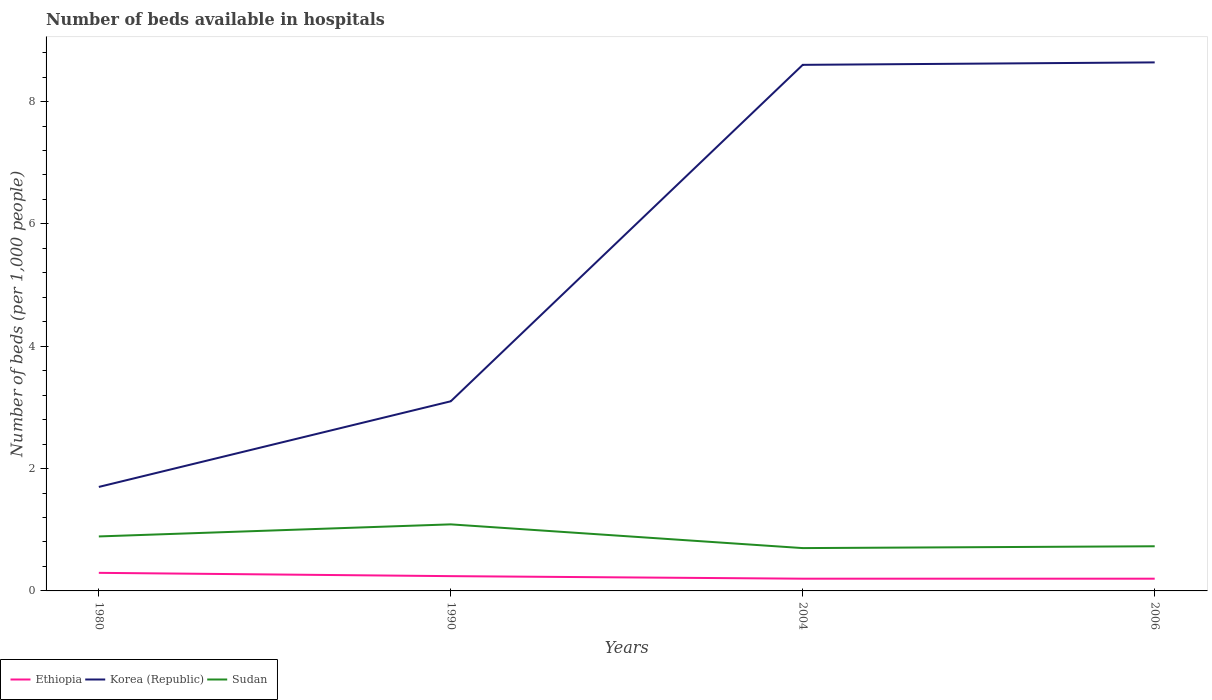Does the line corresponding to Sudan intersect with the line corresponding to Korea (Republic)?
Offer a terse response. No. Is the number of lines equal to the number of legend labels?
Offer a terse response. Yes. In which year was the number of beds in the hospiatls of in Ethiopia maximum?
Offer a terse response. 2004. What is the total number of beds in the hospiatls of in Ethiopia in the graph?
Keep it short and to the point. 0.1. What is the difference between the highest and the second highest number of beds in the hospiatls of in Sudan?
Provide a succinct answer. 0.39. What is the difference between the highest and the lowest number of beds in the hospiatls of in Korea (Republic)?
Your response must be concise. 2. Is the number of beds in the hospiatls of in Korea (Republic) strictly greater than the number of beds in the hospiatls of in Ethiopia over the years?
Offer a very short reply. No. How many years are there in the graph?
Ensure brevity in your answer.  4. Does the graph contain any zero values?
Offer a terse response. No. Where does the legend appear in the graph?
Provide a short and direct response. Bottom left. How are the legend labels stacked?
Your response must be concise. Horizontal. What is the title of the graph?
Ensure brevity in your answer.  Number of beds available in hospitals. What is the label or title of the X-axis?
Your answer should be compact. Years. What is the label or title of the Y-axis?
Offer a terse response. Number of beds (per 1,0 people). What is the Number of beds (per 1,000 people) of Ethiopia in 1980?
Offer a very short reply. 0.3. What is the Number of beds (per 1,000 people) in Korea (Republic) in 1980?
Give a very brief answer. 1.7. What is the Number of beds (per 1,000 people) of Sudan in 1980?
Provide a short and direct response. 0.89. What is the Number of beds (per 1,000 people) of Ethiopia in 1990?
Offer a terse response. 0.24. What is the Number of beds (per 1,000 people) of Korea (Republic) in 1990?
Offer a terse response. 3.1. What is the Number of beds (per 1,000 people) of Sudan in 1990?
Your response must be concise. 1.09. What is the Number of beds (per 1,000 people) in Ethiopia in 2004?
Your response must be concise. 0.2. What is the Number of beds (per 1,000 people) in Ethiopia in 2006?
Give a very brief answer. 0.2. What is the Number of beds (per 1,000 people) of Korea (Republic) in 2006?
Keep it short and to the point. 8.64. What is the Number of beds (per 1,000 people) in Sudan in 2006?
Provide a succinct answer. 0.73. Across all years, what is the maximum Number of beds (per 1,000 people) of Ethiopia?
Keep it short and to the point. 0.3. Across all years, what is the maximum Number of beds (per 1,000 people) of Korea (Republic)?
Your response must be concise. 8.64. Across all years, what is the maximum Number of beds (per 1,000 people) in Sudan?
Make the answer very short. 1.09. Across all years, what is the minimum Number of beds (per 1,000 people) of Ethiopia?
Your answer should be very brief. 0.2. Across all years, what is the minimum Number of beds (per 1,000 people) of Korea (Republic)?
Your answer should be compact. 1.7. What is the total Number of beds (per 1,000 people) in Ethiopia in the graph?
Give a very brief answer. 0.94. What is the total Number of beds (per 1,000 people) in Korea (Republic) in the graph?
Ensure brevity in your answer.  22.04. What is the total Number of beds (per 1,000 people) in Sudan in the graph?
Offer a terse response. 3.41. What is the difference between the Number of beds (per 1,000 people) of Ethiopia in 1980 and that in 1990?
Offer a very short reply. 0.05. What is the difference between the Number of beds (per 1,000 people) in Korea (Republic) in 1980 and that in 1990?
Provide a succinct answer. -1.4. What is the difference between the Number of beds (per 1,000 people) of Sudan in 1980 and that in 1990?
Your answer should be compact. -0.2. What is the difference between the Number of beds (per 1,000 people) in Ethiopia in 1980 and that in 2004?
Give a very brief answer. 0.1. What is the difference between the Number of beds (per 1,000 people) in Sudan in 1980 and that in 2004?
Your answer should be compact. 0.19. What is the difference between the Number of beds (per 1,000 people) of Ethiopia in 1980 and that in 2006?
Keep it short and to the point. 0.1. What is the difference between the Number of beds (per 1,000 people) in Korea (Republic) in 1980 and that in 2006?
Provide a succinct answer. -6.94. What is the difference between the Number of beds (per 1,000 people) in Sudan in 1980 and that in 2006?
Your response must be concise. 0.16. What is the difference between the Number of beds (per 1,000 people) of Ethiopia in 1990 and that in 2004?
Provide a succinct answer. 0.04. What is the difference between the Number of beds (per 1,000 people) in Korea (Republic) in 1990 and that in 2004?
Keep it short and to the point. -5.5. What is the difference between the Number of beds (per 1,000 people) of Sudan in 1990 and that in 2004?
Offer a very short reply. 0.39. What is the difference between the Number of beds (per 1,000 people) of Ethiopia in 1990 and that in 2006?
Give a very brief answer. 0.04. What is the difference between the Number of beds (per 1,000 people) in Korea (Republic) in 1990 and that in 2006?
Offer a terse response. -5.54. What is the difference between the Number of beds (per 1,000 people) in Sudan in 1990 and that in 2006?
Keep it short and to the point. 0.36. What is the difference between the Number of beds (per 1,000 people) in Ethiopia in 2004 and that in 2006?
Your response must be concise. 0. What is the difference between the Number of beds (per 1,000 people) in Korea (Republic) in 2004 and that in 2006?
Make the answer very short. -0.04. What is the difference between the Number of beds (per 1,000 people) in Sudan in 2004 and that in 2006?
Make the answer very short. -0.03. What is the difference between the Number of beds (per 1,000 people) in Ethiopia in 1980 and the Number of beds (per 1,000 people) in Korea (Republic) in 1990?
Keep it short and to the point. -2.8. What is the difference between the Number of beds (per 1,000 people) of Ethiopia in 1980 and the Number of beds (per 1,000 people) of Sudan in 1990?
Give a very brief answer. -0.79. What is the difference between the Number of beds (per 1,000 people) of Korea (Republic) in 1980 and the Number of beds (per 1,000 people) of Sudan in 1990?
Offer a terse response. 0.61. What is the difference between the Number of beds (per 1,000 people) of Ethiopia in 1980 and the Number of beds (per 1,000 people) of Korea (Republic) in 2004?
Keep it short and to the point. -8.3. What is the difference between the Number of beds (per 1,000 people) of Ethiopia in 1980 and the Number of beds (per 1,000 people) of Sudan in 2004?
Provide a succinct answer. -0.4. What is the difference between the Number of beds (per 1,000 people) of Ethiopia in 1980 and the Number of beds (per 1,000 people) of Korea (Republic) in 2006?
Provide a succinct answer. -8.34. What is the difference between the Number of beds (per 1,000 people) in Ethiopia in 1980 and the Number of beds (per 1,000 people) in Sudan in 2006?
Ensure brevity in your answer.  -0.43. What is the difference between the Number of beds (per 1,000 people) in Korea (Republic) in 1980 and the Number of beds (per 1,000 people) in Sudan in 2006?
Your response must be concise. 0.97. What is the difference between the Number of beds (per 1,000 people) in Ethiopia in 1990 and the Number of beds (per 1,000 people) in Korea (Republic) in 2004?
Offer a terse response. -8.36. What is the difference between the Number of beds (per 1,000 people) of Ethiopia in 1990 and the Number of beds (per 1,000 people) of Sudan in 2004?
Your answer should be very brief. -0.46. What is the difference between the Number of beds (per 1,000 people) in Korea (Republic) in 1990 and the Number of beds (per 1,000 people) in Sudan in 2004?
Your answer should be compact. 2.4. What is the difference between the Number of beds (per 1,000 people) of Ethiopia in 1990 and the Number of beds (per 1,000 people) of Korea (Republic) in 2006?
Give a very brief answer. -8.4. What is the difference between the Number of beds (per 1,000 people) in Ethiopia in 1990 and the Number of beds (per 1,000 people) in Sudan in 2006?
Make the answer very short. -0.49. What is the difference between the Number of beds (per 1,000 people) in Korea (Republic) in 1990 and the Number of beds (per 1,000 people) in Sudan in 2006?
Provide a short and direct response. 2.37. What is the difference between the Number of beds (per 1,000 people) of Ethiopia in 2004 and the Number of beds (per 1,000 people) of Korea (Republic) in 2006?
Your response must be concise. -8.44. What is the difference between the Number of beds (per 1,000 people) in Ethiopia in 2004 and the Number of beds (per 1,000 people) in Sudan in 2006?
Your answer should be compact. -0.53. What is the difference between the Number of beds (per 1,000 people) of Korea (Republic) in 2004 and the Number of beds (per 1,000 people) of Sudan in 2006?
Keep it short and to the point. 7.87. What is the average Number of beds (per 1,000 people) of Ethiopia per year?
Your response must be concise. 0.23. What is the average Number of beds (per 1,000 people) of Korea (Republic) per year?
Your response must be concise. 5.51. What is the average Number of beds (per 1,000 people) of Sudan per year?
Your answer should be very brief. 0.85. In the year 1980, what is the difference between the Number of beds (per 1,000 people) of Ethiopia and Number of beds (per 1,000 people) of Korea (Republic)?
Your answer should be compact. -1.4. In the year 1980, what is the difference between the Number of beds (per 1,000 people) in Ethiopia and Number of beds (per 1,000 people) in Sudan?
Give a very brief answer. -0.6. In the year 1980, what is the difference between the Number of beds (per 1,000 people) in Korea (Republic) and Number of beds (per 1,000 people) in Sudan?
Offer a very short reply. 0.81. In the year 1990, what is the difference between the Number of beds (per 1,000 people) of Ethiopia and Number of beds (per 1,000 people) of Korea (Republic)?
Your answer should be very brief. -2.86. In the year 1990, what is the difference between the Number of beds (per 1,000 people) of Ethiopia and Number of beds (per 1,000 people) of Sudan?
Offer a very short reply. -0.85. In the year 1990, what is the difference between the Number of beds (per 1,000 people) in Korea (Republic) and Number of beds (per 1,000 people) in Sudan?
Your answer should be compact. 2.01. In the year 2004, what is the difference between the Number of beds (per 1,000 people) in Ethiopia and Number of beds (per 1,000 people) in Sudan?
Ensure brevity in your answer.  -0.5. In the year 2004, what is the difference between the Number of beds (per 1,000 people) in Korea (Republic) and Number of beds (per 1,000 people) in Sudan?
Make the answer very short. 7.9. In the year 2006, what is the difference between the Number of beds (per 1,000 people) in Ethiopia and Number of beds (per 1,000 people) in Korea (Republic)?
Offer a very short reply. -8.44. In the year 2006, what is the difference between the Number of beds (per 1,000 people) in Ethiopia and Number of beds (per 1,000 people) in Sudan?
Provide a short and direct response. -0.53. In the year 2006, what is the difference between the Number of beds (per 1,000 people) of Korea (Republic) and Number of beds (per 1,000 people) of Sudan?
Your response must be concise. 7.91. What is the ratio of the Number of beds (per 1,000 people) of Ethiopia in 1980 to that in 1990?
Provide a succinct answer. 1.22. What is the ratio of the Number of beds (per 1,000 people) of Korea (Republic) in 1980 to that in 1990?
Ensure brevity in your answer.  0.55. What is the ratio of the Number of beds (per 1,000 people) in Sudan in 1980 to that in 1990?
Give a very brief answer. 0.82. What is the ratio of the Number of beds (per 1,000 people) in Ethiopia in 1980 to that in 2004?
Your answer should be very brief. 1.48. What is the ratio of the Number of beds (per 1,000 people) in Korea (Republic) in 1980 to that in 2004?
Give a very brief answer. 0.2. What is the ratio of the Number of beds (per 1,000 people) in Sudan in 1980 to that in 2004?
Your answer should be very brief. 1.27. What is the ratio of the Number of beds (per 1,000 people) in Ethiopia in 1980 to that in 2006?
Keep it short and to the point. 1.48. What is the ratio of the Number of beds (per 1,000 people) of Korea (Republic) in 1980 to that in 2006?
Your response must be concise. 0.2. What is the ratio of the Number of beds (per 1,000 people) of Sudan in 1980 to that in 2006?
Your answer should be very brief. 1.22. What is the ratio of the Number of beds (per 1,000 people) in Ethiopia in 1990 to that in 2004?
Your answer should be very brief. 1.21. What is the ratio of the Number of beds (per 1,000 people) in Korea (Republic) in 1990 to that in 2004?
Your response must be concise. 0.36. What is the ratio of the Number of beds (per 1,000 people) of Sudan in 1990 to that in 2004?
Offer a very short reply. 1.55. What is the ratio of the Number of beds (per 1,000 people) of Ethiopia in 1990 to that in 2006?
Your response must be concise. 1.21. What is the ratio of the Number of beds (per 1,000 people) of Korea (Republic) in 1990 to that in 2006?
Offer a terse response. 0.36. What is the ratio of the Number of beds (per 1,000 people) of Sudan in 1990 to that in 2006?
Offer a terse response. 1.49. What is the ratio of the Number of beds (per 1,000 people) of Ethiopia in 2004 to that in 2006?
Your response must be concise. 1. What is the ratio of the Number of beds (per 1,000 people) of Korea (Republic) in 2004 to that in 2006?
Your response must be concise. 1. What is the ratio of the Number of beds (per 1,000 people) in Sudan in 2004 to that in 2006?
Ensure brevity in your answer.  0.96. What is the difference between the highest and the second highest Number of beds (per 1,000 people) of Ethiopia?
Keep it short and to the point. 0.05. What is the difference between the highest and the second highest Number of beds (per 1,000 people) in Sudan?
Make the answer very short. 0.2. What is the difference between the highest and the lowest Number of beds (per 1,000 people) in Ethiopia?
Make the answer very short. 0.1. What is the difference between the highest and the lowest Number of beds (per 1,000 people) in Korea (Republic)?
Provide a succinct answer. 6.94. What is the difference between the highest and the lowest Number of beds (per 1,000 people) in Sudan?
Your response must be concise. 0.39. 